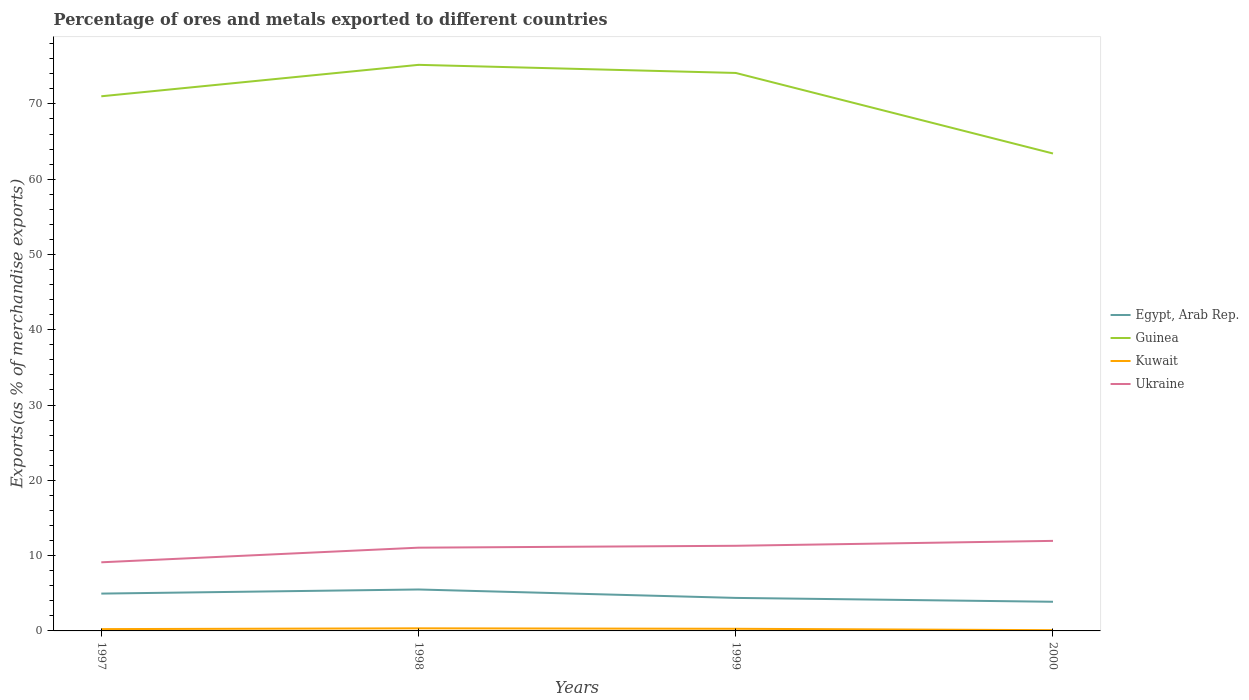Is the number of lines equal to the number of legend labels?
Offer a terse response. Yes. Across all years, what is the maximum percentage of exports to different countries in Guinea?
Provide a succinct answer. 63.41. What is the total percentage of exports to different countries in Ukraine in the graph?
Provide a short and direct response. -2.85. What is the difference between the highest and the second highest percentage of exports to different countries in Kuwait?
Your answer should be very brief. 0.24. Is the percentage of exports to different countries in Egypt, Arab Rep. strictly greater than the percentage of exports to different countries in Guinea over the years?
Ensure brevity in your answer.  Yes. How many years are there in the graph?
Keep it short and to the point. 4. What is the difference between two consecutive major ticks on the Y-axis?
Your answer should be very brief. 10. Are the values on the major ticks of Y-axis written in scientific E-notation?
Your response must be concise. No. Does the graph contain grids?
Ensure brevity in your answer.  No. Where does the legend appear in the graph?
Make the answer very short. Center right. What is the title of the graph?
Ensure brevity in your answer.  Percentage of ores and metals exported to different countries. What is the label or title of the X-axis?
Ensure brevity in your answer.  Years. What is the label or title of the Y-axis?
Your answer should be very brief. Exports(as % of merchandise exports). What is the Exports(as % of merchandise exports) in Egypt, Arab Rep. in 1997?
Give a very brief answer. 4.96. What is the Exports(as % of merchandise exports) in Guinea in 1997?
Give a very brief answer. 71.01. What is the Exports(as % of merchandise exports) of Kuwait in 1997?
Ensure brevity in your answer.  0.24. What is the Exports(as % of merchandise exports) in Ukraine in 1997?
Make the answer very short. 9.11. What is the Exports(as % of merchandise exports) of Egypt, Arab Rep. in 1998?
Make the answer very short. 5.5. What is the Exports(as % of merchandise exports) of Guinea in 1998?
Your answer should be very brief. 75.19. What is the Exports(as % of merchandise exports) in Kuwait in 1998?
Offer a terse response. 0.35. What is the Exports(as % of merchandise exports) of Ukraine in 1998?
Offer a terse response. 11.06. What is the Exports(as % of merchandise exports) in Egypt, Arab Rep. in 1999?
Give a very brief answer. 4.39. What is the Exports(as % of merchandise exports) of Guinea in 1999?
Provide a short and direct response. 74.11. What is the Exports(as % of merchandise exports) of Kuwait in 1999?
Your response must be concise. 0.28. What is the Exports(as % of merchandise exports) in Ukraine in 1999?
Your answer should be compact. 11.31. What is the Exports(as % of merchandise exports) of Egypt, Arab Rep. in 2000?
Provide a short and direct response. 3.87. What is the Exports(as % of merchandise exports) of Guinea in 2000?
Offer a very short reply. 63.41. What is the Exports(as % of merchandise exports) of Kuwait in 2000?
Your response must be concise. 0.1. What is the Exports(as % of merchandise exports) of Ukraine in 2000?
Offer a terse response. 11.96. Across all years, what is the maximum Exports(as % of merchandise exports) of Egypt, Arab Rep.?
Your answer should be very brief. 5.5. Across all years, what is the maximum Exports(as % of merchandise exports) of Guinea?
Keep it short and to the point. 75.19. Across all years, what is the maximum Exports(as % of merchandise exports) in Kuwait?
Your answer should be compact. 0.35. Across all years, what is the maximum Exports(as % of merchandise exports) in Ukraine?
Ensure brevity in your answer.  11.96. Across all years, what is the minimum Exports(as % of merchandise exports) of Egypt, Arab Rep.?
Offer a very short reply. 3.87. Across all years, what is the minimum Exports(as % of merchandise exports) of Guinea?
Give a very brief answer. 63.41. Across all years, what is the minimum Exports(as % of merchandise exports) of Kuwait?
Your answer should be compact. 0.1. Across all years, what is the minimum Exports(as % of merchandise exports) in Ukraine?
Your answer should be very brief. 9.11. What is the total Exports(as % of merchandise exports) in Egypt, Arab Rep. in the graph?
Your response must be concise. 18.72. What is the total Exports(as % of merchandise exports) of Guinea in the graph?
Keep it short and to the point. 283.72. What is the total Exports(as % of merchandise exports) in Kuwait in the graph?
Keep it short and to the point. 0.97. What is the total Exports(as % of merchandise exports) of Ukraine in the graph?
Your answer should be very brief. 43.44. What is the difference between the Exports(as % of merchandise exports) in Egypt, Arab Rep. in 1997 and that in 1998?
Ensure brevity in your answer.  -0.55. What is the difference between the Exports(as % of merchandise exports) in Guinea in 1997 and that in 1998?
Make the answer very short. -4.18. What is the difference between the Exports(as % of merchandise exports) in Kuwait in 1997 and that in 1998?
Your answer should be compact. -0.1. What is the difference between the Exports(as % of merchandise exports) of Ukraine in 1997 and that in 1998?
Offer a terse response. -1.94. What is the difference between the Exports(as % of merchandise exports) of Egypt, Arab Rep. in 1997 and that in 1999?
Your answer should be compact. 0.57. What is the difference between the Exports(as % of merchandise exports) in Guinea in 1997 and that in 1999?
Make the answer very short. -3.1. What is the difference between the Exports(as % of merchandise exports) of Kuwait in 1997 and that in 1999?
Your response must be concise. -0.04. What is the difference between the Exports(as % of merchandise exports) of Ukraine in 1997 and that in 1999?
Keep it short and to the point. -2.19. What is the difference between the Exports(as % of merchandise exports) in Egypt, Arab Rep. in 1997 and that in 2000?
Make the answer very short. 1.09. What is the difference between the Exports(as % of merchandise exports) in Kuwait in 1997 and that in 2000?
Offer a very short reply. 0.14. What is the difference between the Exports(as % of merchandise exports) of Ukraine in 1997 and that in 2000?
Provide a succinct answer. -2.85. What is the difference between the Exports(as % of merchandise exports) of Egypt, Arab Rep. in 1998 and that in 1999?
Keep it short and to the point. 1.12. What is the difference between the Exports(as % of merchandise exports) of Guinea in 1998 and that in 1999?
Give a very brief answer. 1.08. What is the difference between the Exports(as % of merchandise exports) in Kuwait in 1998 and that in 1999?
Offer a very short reply. 0.06. What is the difference between the Exports(as % of merchandise exports) of Ukraine in 1998 and that in 1999?
Keep it short and to the point. -0.25. What is the difference between the Exports(as % of merchandise exports) of Egypt, Arab Rep. in 1998 and that in 2000?
Your response must be concise. 1.63. What is the difference between the Exports(as % of merchandise exports) in Guinea in 1998 and that in 2000?
Provide a short and direct response. 11.78. What is the difference between the Exports(as % of merchandise exports) of Kuwait in 1998 and that in 2000?
Provide a short and direct response. 0.24. What is the difference between the Exports(as % of merchandise exports) of Ukraine in 1998 and that in 2000?
Your response must be concise. -0.9. What is the difference between the Exports(as % of merchandise exports) of Egypt, Arab Rep. in 1999 and that in 2000?
Your response must be concise. 0.51. What is the difference between the Exports(as % of merchandise exports) of Guinea in 1999 and that in 2000?
Make the answer very short. 10.7. What is the difference between the Exports(as % of merchandise exports) in Kuwait in 1999 and that in 2000?
Your answer should be compact. 0.18. What is the difference between the Exports(as % of merchandise exports) in Ukraine in 1999 and that in 2000?
Ensure brevity in your answer.  -0.65. What is the difference between the Exports(as % of merchandise exports) of Egypt, Arab Rep. in 1997 and the Exports(as % of merchandise exports) of Guinea in 1998?
Keep it short and to the point. -70.23. What is the difference between the Exports(as % of merchandise exports) of Egypt, Arab Rep. in 1997 and the Exports(as % of merchandise exports) of Kuwait in 1998?
Your response must be concise. 4.61. What is the difference between the Exports(as % of merchandise exports) in Egypt, Arab Rep. in 1997 and the Exports(as % of merchandise exports) in Ukraine in 1998?
Keep it short and to the point. -6.1. What is the difference between the Exports(as % of merchandise exports) in Guinea in 1997 and the Exports(as % of merchandise exports) in Kuwait in 1998?
Your answer should be very brief. 70.67. What is the difference between the Exports(as % of merchandise exports) of Guinea in 1997 and the Exports(as % of merchandise exports) of Ukraine in 1998?
Offer a terse response. 59.95. What is the difference between the Exports(as % of merchandise exports) in Kuwait in 1997 and the Exports(as % of merchandise exports) in Ukraine in 1998?
Provide a short and direct response. -10.82. What is the difference between the Exports(as % of merchandise exports) in Egypt, Arab Rep. in 1997 and the Exports(as % of merchandise exports) in Guinea in 1999?
Keep it short and to the point. -69.15. What is the difference between the Exports(as % of merchandise exports) in Egypt, Arab Rep. in 1997 and the Exports(as % of merchandise exports) in Kuwait in 1999?
Make the answer very short. 4.67. What is the difference between the Exports(as % of merchandise exports) in Egypt, Arab Rep. in 1997 and the Exports(as % of merchandise exports) in Ukraine in 1999?
Provide a short and direct response. -6.35. What is the difference between the Exports(as % of merchandise exports) in Guinea in 1997 and the Exports(as % of merchandise exports) in Kuwait in 1999?
Provide a succinct answer. 70.73. What is the difference between the Exports(as % of merchandise exports) in Guinea in 1997 and the Exports(as % of merchandise exports) in Ukraine in 1999?
Offer a terse response. 59.7. What is the difference between the Exports(as % of merchandise exports) of Kuwait in 1997 and the Exports(as % of merchandise exports) of Ukraine in 1999?
Offer a very short reply. -11.07. What is the difference between the Exports(as % of merchandise exports) in Egypt, Arab Rep. in 1997 and the Exports(as % of merchandise exports) in Guinea in 2000?
Provide a short and direct response. -58.45. What is the difference between the Exports(as % of merchandise exports) in Egypt, Arab Rep. in 1997 and the Exports(as % of merchandise exports) in Kuwait in 2000?
Make the answer very short. 4.86. What is the difference between the Exports(as % of merchandise exports) of Egypt, Arab Rep. in 1997 and the Exports(as % of merchandise exports) of Ukraine in 2000?
Your answer should be very brief. -7. What is the difference between the Exports(as % of merchandise exports) in Guinea in 1997 and the Exports(as % of merchandise exports) in Kuwait in 2000?
Offer a terse response. 70.91. What is the difference between the Exports(as % of merchandise exports) of Guinea in 1997 and the Exports(as % of merchandise exports) of Ukraine in 2000?
Your response must be concise. 59.05. What is the difference between the Exports(as % of merchandise exports) of Kuwait in 1997 and the Exports(as % of merchandise exports) of Ukraine in 2000?
Offer a terse response. -11.72. What is the difference between the Exports(as % of merchandise exports) in Egypt, Arab Rep. in 1998 and the Exports(as % of merchandise exports) in Guinea in 1999?
Provide a succinct answer. -68.61. What is the difference between the Exports(as % of merchandise exports) of Egypt, Arab Rep. in 1998 and the Exports(as % of merchandise exports) of Kuwait in 1999?
Your answer should be compact. 5.22. What is the difference between the Exports(as % of merchandise exports) of Egypt, Arab Rep. in 1998 and the Exports(as % of merchandise exports) of Ukraine in 1999?
Offer a terse response. -5.8. What is the difference between the Exports(as % of merchandise exports) in Guinea in 1998 and the Exports(as % of merchandise exports) in Kuwait in 1999?
Ensure brevity in your answer.  74.9. What is the difference between the Exports(as % of merchandise exports) in Guinea in 1998 and the Exports(as % of merchandise exports) in Ukraine in 1999?
Make the answer very short. 63.88. What is the difference between the Exports(as % of merchandise exports) in Kuwait in 1998 and the Exports(as % of merchandise exports) in Ukraine in 1999?
Offer a very short reply. -10.96. What is the difference between the Exports(as % of merchandise exports) in Egypt, Arab Rep. in 1998 and the Exports(as % of merchandise exports) in Guinea in 2000?
Your answer should be very brief. -57.91. What is the difference between the Exports(as % of merchandise exports) of Egypt, Arab Rep. in 1998 and the Exports(as % of merchandise exports) of Kuwait in 2000?
Keep it short and to the point. 5.4. What is the difference between the Exports(as % of merchandise exports) of Egypt, Arab Rep. in 1998 and the Exports(as % of merchandise exports) of Ukraine in 2000?
Ensure brevity in your answer.  -6.46. What is the difference between the Exports(as % of merchandise exports) in Guinea in 1998 and the Exports(as % of merchandise exports) in Kuwait in 2000?
Offer a terse response. 75.09. What is the difference between the Exports(as % of merchandise exports) of Guinea in 1998 and the Exports(as % of merchandise exports) of Ukraine in 2000?
Provide a succinct answer. 63.23. What is the difference between the Exports(as % of merchandise exports) of Kuwait in 1998 and the Exports(as % of merchandise exports) of Ukraine in 2000?
Your answer should be compact. -11.62. What is the difference between the Exports(as % of merchandise exports) in Egypt, Arab Rep. in 1999 and the Exports(as % of merchandise exports) in Guinea in 2000?
Provide a short and direct response. -59.03. What is the difference between the Exports(as % of merchandise exports) in Egypt, Arab Rep. in 1999 and the Exports(as % of merchandise exports) in Kuwait in 2000?
Give a very brief answer. 4.29. What is the difference between the Exports(as % of merchandise exports) of Egypt, Arab Rep. in 1999 and the Exports(as % of merchandise exports) of Ukraine in 2000?
Your answer should be compact. -7.58. What is the difference between the Exports(as % of merchandise exports) in Guinea in 1999 and the Exports(as % of merchandise exports) in Kuwait in 2000?
Make the answer very short. 74.01. What is the difference between the Exports(as % of merchandise exports) in Guinea in 1999 and the Exports(as % of merchandise exports) in Ukraine in 2000?
Your answer should be very brief. 62.15. What is the difference between the Exports(as % of merchandise exports) in Kuwait in 1999 and the Exports(as % of merchandise exports) in Ukraine in 2000?
Provide a short and direct response. -11.68. What is the average Exports(as % of merchandise exports) in Egypt, Arab Rep. per year?
Offer a very short reply. 4.68. What is the average Exports(as % of merchandise exports) in Guinea per year?
Provide a succinct answer. 70.93. What is the average Exports(as % of merchandise exports) in Kuwait per year?
Give a very brief answer. 0.24. What is the average Exports(as % of merchandise exports) in Ukraine per year?
Ensure brevity in your answer.  10.86. In the year 1997, what is the difference between the Exports(as % of merchandise exports) of Egypt, Arab Rep. and Exports(as % of merchandise exports) of Guinea?
Make the answer very short. -66.05. In the year 1997, what is the difference between the Exports(as % of merchandise exports) in Egypt, Arab Rep. and Exports(as % of merchandise exports) in Kuwait?
Offer a terse response. 4.72. In the year 1997, what is the difference between the Exports(as % of merchandise exports) in Egypt, Arab Rep. and Exports(as % of merchandise exports) in Ukraine?
Offer a terse response. -4.16. In the year 1997, what is the difference between the Exports(as % of merchandise exports) in Guinea and Exports(as % of merchandise exports) in Kuwait?
Offer a terse response. 70.77. In the year 1997, what is the difference between the Exports(as % of merchandise exports) of Guinea and Exports(as % of merchandise exports) of Ukraine?
Offer a very short reply. 61.9. In the year 1997, what is the difference between the Exports(as % of merchandise exports) of Kuwait and Exports(as % of merchandise exports) of Ukraine?
Ensure brevity in your answer.  -8.87. In the year 1998, what is the difference between the Exports(as % of merchandise exports) of Egypt, Arab Rep. and Exports(as % of merchandise exports) of Guinea?
Your response must be concise. -69.68. In the year 1998, what is the difference between the Exports(as % of merchandise exports) of Egypt, Arab Rep. and Exports(as % of merchandise exports) of Kuwait?
Ensure brevity in your answer.  5.16. In the year 1998, what is the difference between the Exports(as % of merchandise exports) in Egypt, Arab Rep. and Exports(as % of merchandise exports) in Ukraine?
Your response must be concise. -5.55. In the year 1998, what is the difference between the Exports(as % of merchandise exports) of Guinea and Exports(as % of merchandise exports) of Kuwait?
Offer a terse response. 74.84. In the year 1998, what is the difference between the Exports(as % of merchandise exports) in Guinea and Exports(as % of merchandise exports) in Ukraine?
Your answer should be compact. 64.13. In the year 1998, what is the difference between the Exports(as % of merchandise exports) in Kuwait and Exports(as % of merchandise exports) in Ukraine?
Offer a terse response. -10.71. In the year 1999, what is the difference between the Exports(as % of merchandise exports) of Egypt, Arab Rep. and Exports(as % of merchandise exports) of Guinea?
Your response must be concise. -69.73. In the year 1999, what is the difference between the Exports(as % of merchandise exports) in Egypt, Arab Rep. and Exports(as % of merchandise exports) in Kuwait?
Your answer should be very brief. 4.1. In the year 1999, what is the difference between the Exports(as % of merchandise exports) in Egypt, Arab Rep. and Exports(as % of merchandise exports) in Ukraine?
Provide a succinct answer. -6.92. In the year 1999, what is the difference between the Exports(as % of merchandise exports) of Guinea and Exports(as % of merchandise exports) of Kuwait?
Your answer should be very brief. 73.83. In the year 1999, what is the difference between the Exports(as % of merchandise exports) in Guinea and Exports(as % of merchandise exports) in Ukraine?
Provide a succinct answer. 62.8. In the year 1999, what is the difference between the Exports(as % of merchandise exports) of Kuwait and Exports(as % of merchandise exports) of Ukraine?
Provide a short and direct response. -11.02. In the year 2000, what is the difference between the Exports(as % of merchandise exports) in Egypt, Arab Rep. and Exports(as % of merchandise exports) in Guinea?
Your answer should be very brief. -59.54. In the year 2000, what is the difference between the Exports(as % of merchandise exports) of Egypt, Arab Rep. and Exports(as % of merchandise exports) of Kuwait?
Provide a succinct answer. 3.77. In the year 2000, what is the difference between the Exports(as % of merchandise exports) in Egypt, Arab Rep. and Exports(as % of merchandise exports) in Ukraine?
Provide a succinct answer. -8.09. In the year 2000, what is the difference between the Exports(as % of merchandise exports) in Guinea and Exports(as % of merchandise exports) in Kuwait?
Your answer should be compact. 63.31. In the year 2000, what is the difference between the Exports(as % of merchandise exports) of Guinea and Exports(as % of merchandise exports) of Ukraine?
Your answer should be compact. 51.45. In the year 2000, what is the difference between the Exports(as % of merchandise exports) of Kuwait and Exports(as % of merchandise exports) of Ukraine?
Provide a succinct answer. -11.86. What is the ratio of the Exports(as % of merchandise exports) in Egypt, Arab Rep. in 1997 to that in 1998?
Keep it short and to the point. 0.9. What is the ratio of the Exports(as % of merchandise exports) in Guinea in 1997 to that in 1998?
Provide a short and direct response. 0.94. What is the ratio of the Exports(as % of merchandise exports) in Kuwait in 1997 to that in 1998?
Offer a terse response. 0.7. What is the ratio of the Exports(as % of merchandise exports) in Ukraine in 1997 to that in 1998?
Keep it short and to the point. 0.82. What is the ratio of the Exports(as % of merchandise exports) of Egypt, Arab Rep. in 1997 to that in 1999?
Your answer should be compact. 1.13. What is the ratio of the Exports(as % of merchandise exports) of Guinea in 1997 to that in 1999?
Your answer should be compact. 0.96. What is the ratio of the Exports(as % of merchandise exports) in Kuwait in 1997 to that in 1999?
Your answer should be compact. 0.85. What is the ratio of the Exports(as % of merchandise exports) of Ukraine in 1997 to that in 1999?
Keep it short and to the point. 0.81. What is the ratio of the Exports(as % of merchandise exports) of Egypt, Arab Rep. in 1997 to that in 2000?
Ensure brevity in your answer.  1.28. What is the ratio of the Exports(as % of merchandise exports) in Guinea in 1997 to that in 2000?
Give a very brief answer. 1.12. What is the ratio of the Exports(as % of merchandise exports) of Kuwait in 1997 to that in 2000?
Provide a short and direct response. 2.41. What is the ratio of the Exports(as % of merchandise exports) in Ukraine in 1997 to that in 2000?
Keep it short and to the point. 0.76. What is the ratio of the Exports(as % of merchandise exports) in Egypt, Arab Rep. in 1998 to that in 1999?
Provide a short and direct response. 1.26. What is the ratio of the Exports(as % of merchandise exports) of Guinea in 1998 to that in 1999?
Offer a very short reply. 1.01. What is the ratio of the Exports(as % of merchandise exports) in Kuwait in 1998 to that in 1999?
Your answer should be compact. 1.21. What is the ratio of the Exports(as % of merchandise exports) of Ukraine in 1998 to that in 1999?
Give a very brief answer. 0.98. What is the ratio of the Exports(as % of merchandise exports) of Egypt, Arab Rep. in 1998 to that in 2000?
Offer a terse response. 1.42. What is the ratio of the Exports(as % of merchandise exports) in Guinea in 1998 to that in 2000?
Ensure brevity in your answer.  1.19. What is the ratio of the Exports(as % of merchandise exports) in Kuwait in 1998 to that in 2000?
Provide a succinct answer. 3.45. What is the ratio of the Exports(as % of merchandise exports) of Ukraine in 1998 to that in 2000?
Give a very brief answer. 0.92. What is the ratio of the Exports(as % of merchandise exports) of Egypt, Arab Rep. in 1999 to that in 2000?
Keep it short and to the point. 1.13. What is the ratio of the Exports(as % of merchandise exports) in Guinea in 1999 to that in 2000?
Offer a very short reply. 1.17. What is the ratio of the Exports(as % of merchandise exports) of Kuwait in 1999 to that in 2000?
Offer a terse response. 2.84. What is the ratio of the Exports(as % of merchandise exports) in Ukraine in 1999 to that in 2000?
Your response must be concise. 0.95. What is the difference between the highest and the second highest Exports(as % of merchandise exports) in Egypt, Arab Rep.?
Your answer should be compact. 0.55. What is the difference between the highest and the second highest Exports(as % of merchandise exports) in Guinea?
Your response must be concise. 1.08. What is the difference between the highest and the second highest Exports(as % of merchandise exports) in Kuwait?
Keep it short and to the point. 0.06. What is the difference between the highest and the second highest Exports(as % of merchandise exports) of Ukraine?
Ensure brevity in your answer.  0.65. What is the difference between the highest and the lowest Exports(as % of merchandise exports) of Egypt, Arab Rep.?
Give a very brief answer. 1.63. What is the difference between the highest and the lowest Exports(as % of merchandise exports) of Guinea?
Make the answer very short. 11.78. What is the difference between the highest and the lowest Exports(as % of merchandise exports) of Kuwait?
Your answer should be very brief. 0.24. What is the difference between the highest and the lowest Exports(as % of merchandise exports) in Ukraine?
Offer a terse response. 2.85. 